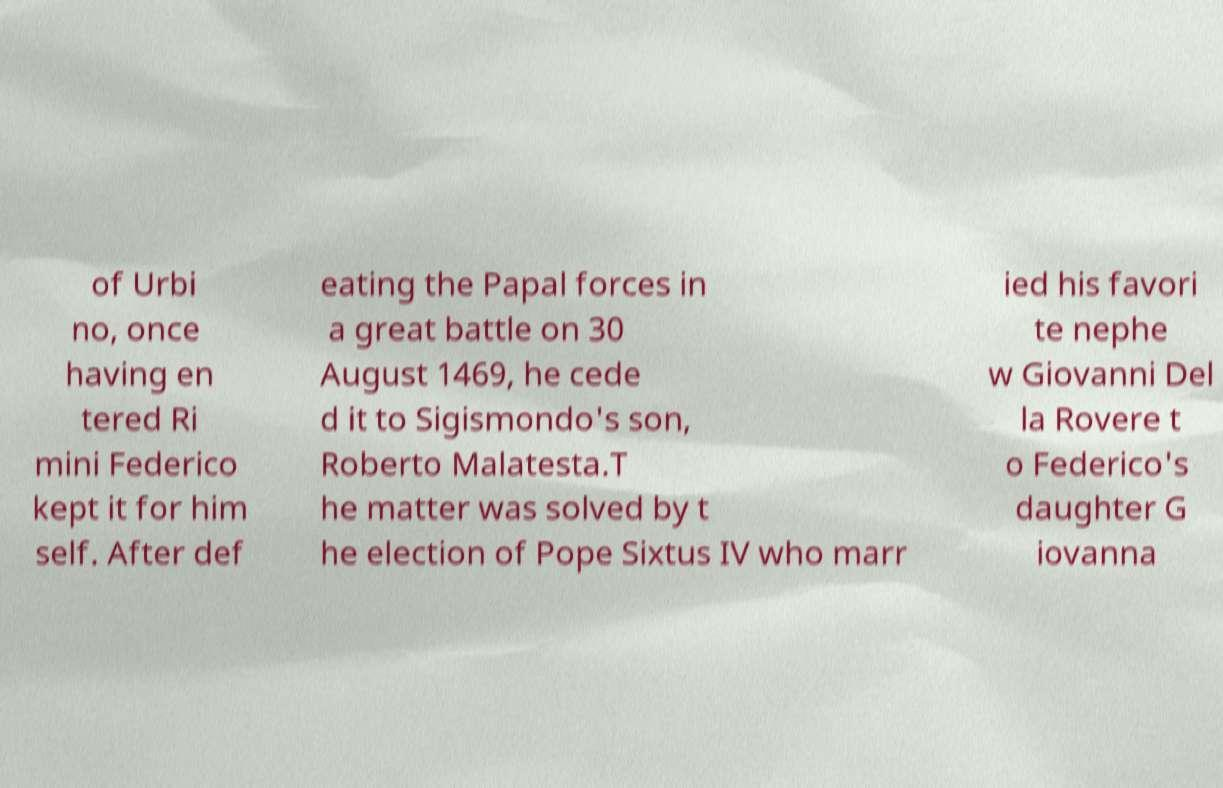Could you assist in decoding the text presented in this image and type it out clearly? of Urbi no, once having en tered Ri mini Federico kept it for him self. After def eating the Papal forces in a great battle on 30 August 1469, he cede d it to Sigismondo's son, Roberto Malatesta.T he matter was solved by t he election of Pope Sixtus IV who marr ied his favori te nephe w Giovanni Del la Rovere t o Federico's daughter G iovanna 